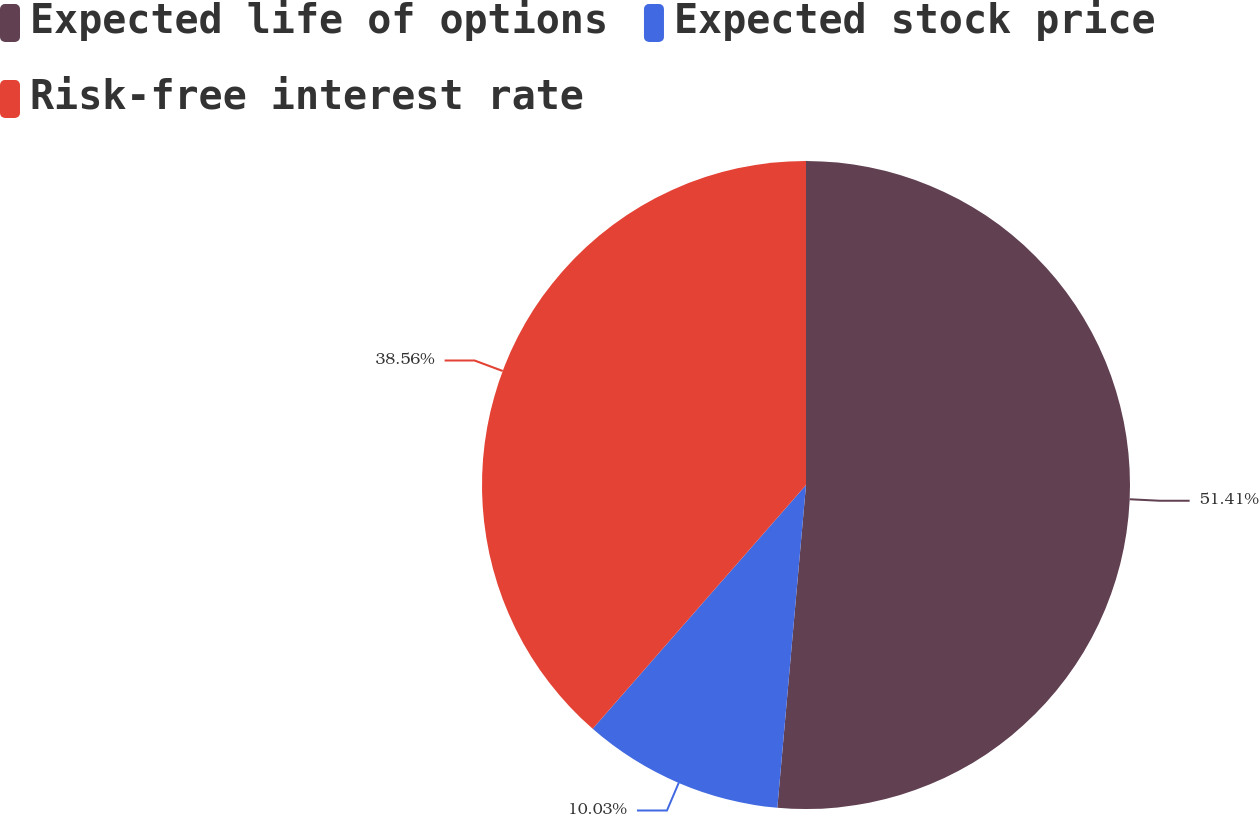<chart> <loc_0><loc_0><loc_500><loc_500><pie_chart><fcel>Expected life of options<fcel>Expected stock price<fcel>Risk-free interest rate<nl><fcel>51.41%<fcel>10.03%<fcel>38.56%<nl></chart> 